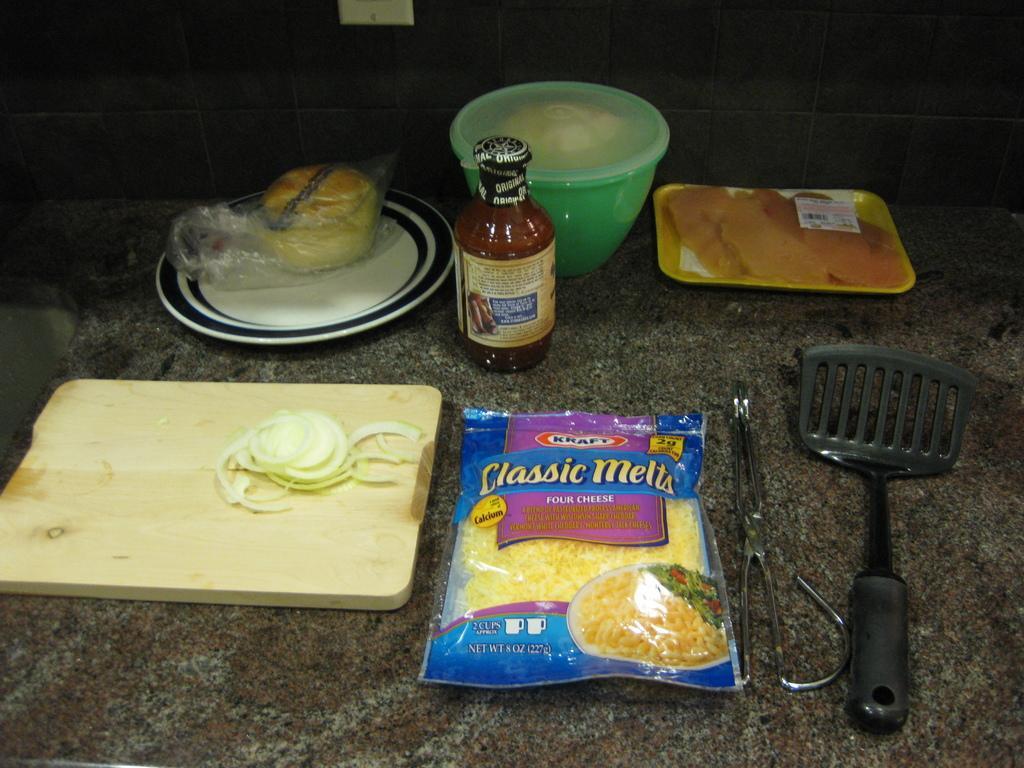Could you give a brief overview of what you see in this image? There is a table. There is a bowl,bottle,plate,bun,tray on a table. 